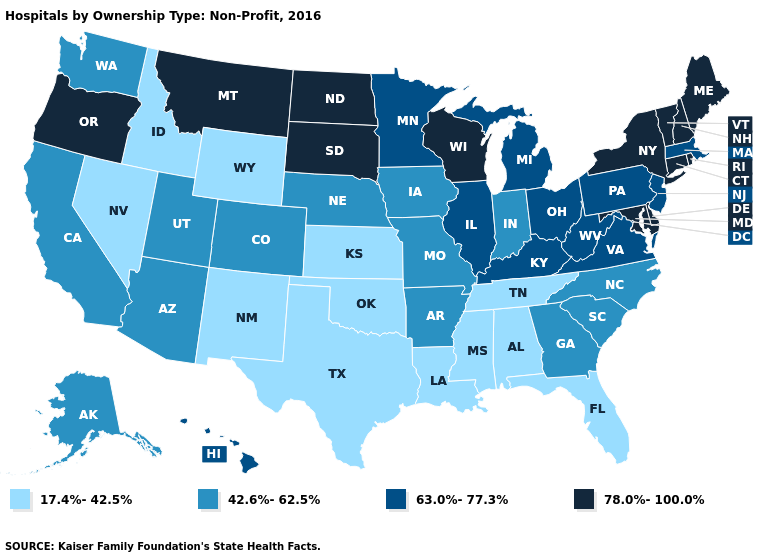Which states hav the highest value in the West?
Be succinct. Montana, Oregon. What is the lowest value in states that border West Virginia?
Keep it brief. 63.0%-77.3%. Among the states that border Missouri , does Kansas have the lowest value?
Keep it brief. Yes. Name the states that have a value in the range 17.4%-42.5%?
Answer briefly. Alabama, Florida, Idaho, Kansas, Louisiana, Mississippi, Nevada, New Mexico, Oklahoma, Tennessee, Texas, Wyoming. What is the highest value in states that border Ohio?
Write a very short answer. 63.0%-77.3%. Name the states that have a value in the range 42.6%-62.5%?
Answer briefly. Alaska, Arizona, Arkansas, California, Colorado, Georgia, Indiana, Iowa, Missouri, Nebraska, North Carolina, South Carolina, Utah, Washington. Does Michigan have a lower value than North Dakota?
Write a very short answer. Yes. What is the lowest value in the Northeast?
Write a very short answer. 63.0%-77.3%. How many symbols are there in the legend?
Concise answer only. 4. What is the lowest value in the USA?
Short answer required. 17.4%-42.5%. Does the first symbol in the legend represent the smallest category?
Be succinct. Yes. What is the highest value in the MidWest ?
Write a very short answer. 78.0%-100.0%. What is the lowest value in the USA?
Quick response, please. 17.4%-42.5%. What is the value of Connecticut?
Write a very short answer. 78.0%-100.0%. What is the value of New York?
Be succinct. 78.0%-100.0%. 